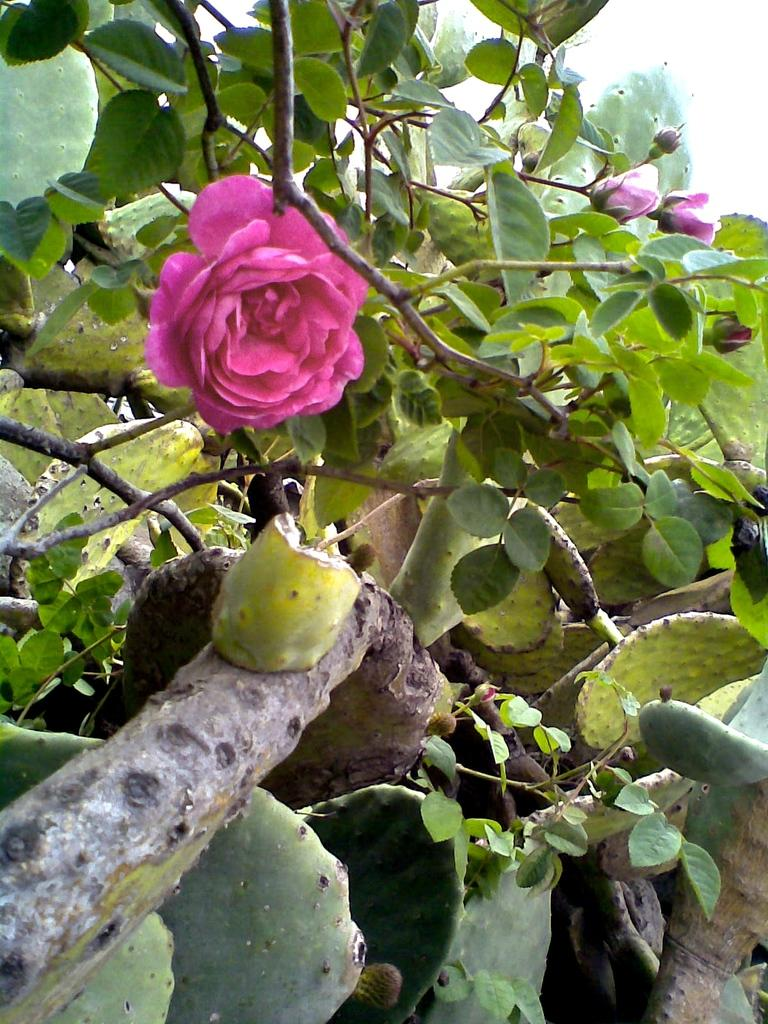What type of living organisms can be seen in the picture? Plants can be seen in the picture. What specific features can be observed on the plants? The plants have flowers and buds. What part of the plants is responsible for achieving success in the image? There is no indication in the image that the plants are achieving success or that any part of the plants is responsible for such achievements. 